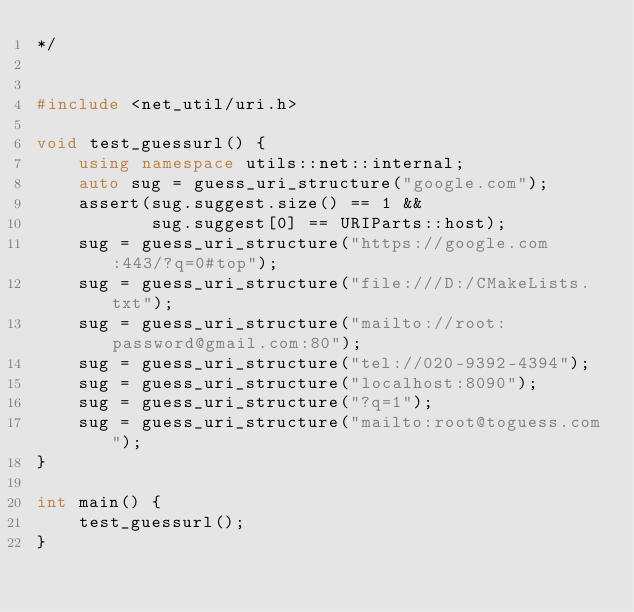Convert code to text. <code><loc_0><loc_0><loc_500><loc_500><_C++_>*/


#include <net_util/uri.h>

void test_guessurl() {
    using namespace utils::net::internal;
    auto sug = guess_uri_structure("google.com");
    assert(sug.suggest.size() == 1 &&
           sug.suggest[0] == URIParts::host);
    sug = guess_uri_structure("https://google.com:443/?q=0#top");
    sug = guess_uri_structure("file:///D:/CMakeLists.txt");
    sug = guess_uri_structure("mailto://root:password@gmail.com:80");
    sug = guess_uri_structure("tel://020-9392-4394");
    sug = guess_uri_structure("localhost:8090");
    sug = guess_uri_structure("?q=1");
    sug = guess_uri_structure("mailto:root@toguess.com");
}

int main() {
    test_guessurl();
}
</code> 